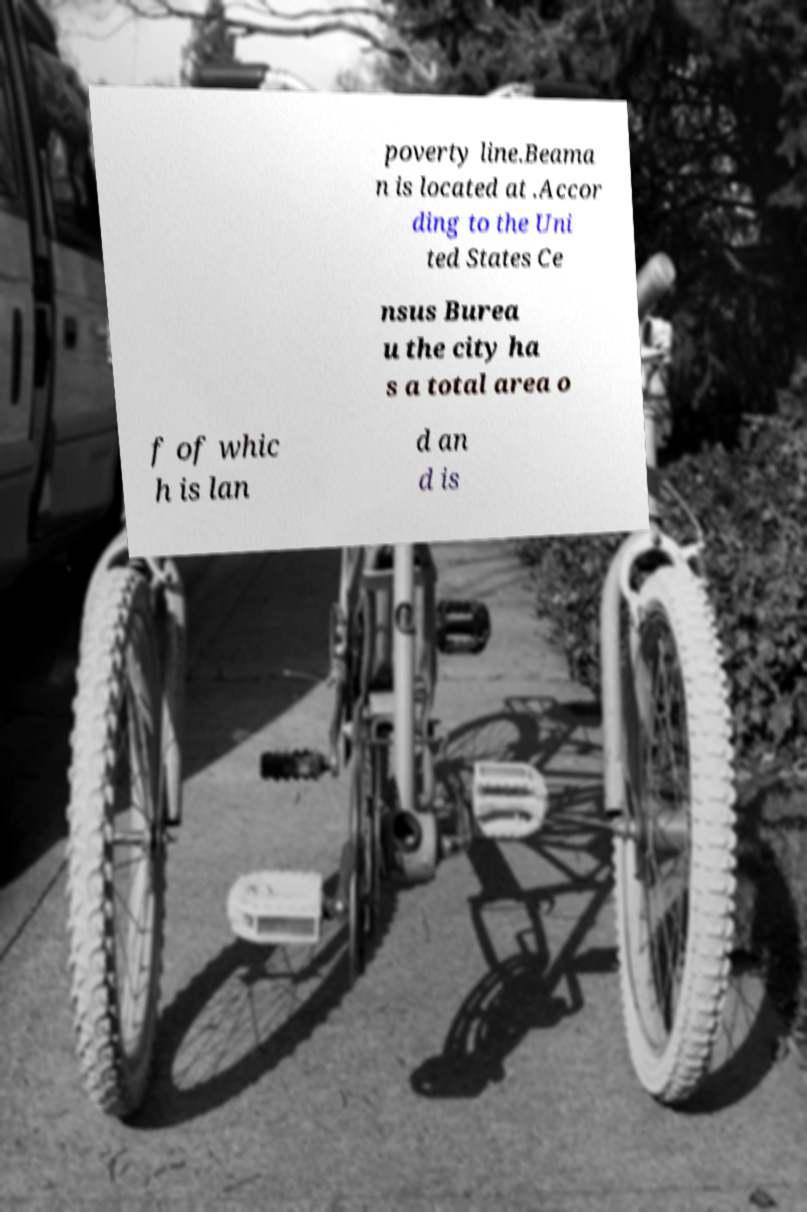For documentation purposes, I need the text within this image transcribed. Could you provide that? poverty line.Beama n is located at .Accor ding to the Uni ted States Ce nsus Burea u the city ha s a total area o f of whic h is lan d an d is 